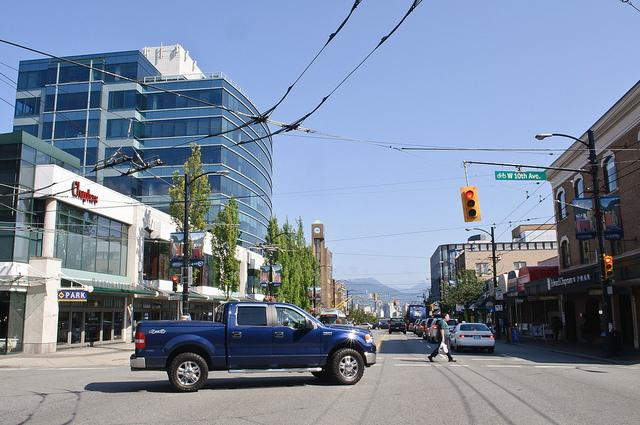What is the make of the blue pickup truck?

Choices:
A) chevrolet
B) ford
C) toyota
D) gmc ford 